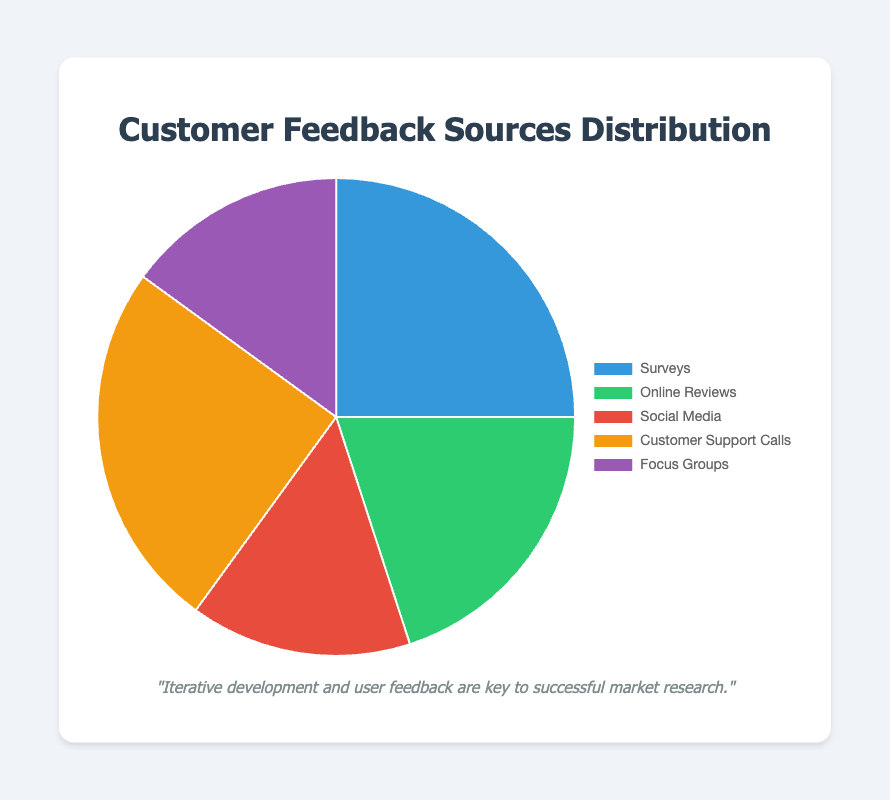What is the total percentage of feedback that comes from Surveys and Customer Support Calls? To find the total percentage of feedback that comes from Surveys and Customer Support Calls, we sum their percentages: 25% (Surveys) + 25% (Customer Support Calls) = 50%.
Answer: 50% Which feedback source contributes the least to the overall distribution? By comparing the given percentages, Social Media and Focus Groups both have the lowest contributions at 15% each.
Answer: Social Media and Focus Groups How much more feedback do Surveys generate compared to Social Media? Surveys generate 25% and Social Media generate 15%. The difference is 25% - 15% = 10%.
Answer: 10% What percentage of feedback comes from sources other than Online Reviews? To find the percentage of feedback from sources other than Online Reviews, we subtract the percentage of Online Reviews from 100%: 100% - 20% = 80%.
Answer: 80% Is the feedback from Customer Support Calls equal to that from Surveys? Yes, both Customer Support Calls and Surveys contribute 25% each to the overall distribution.
Answer: Yes Which sector provides more feedback: Focus Groups or Online Reviews? Online Reviews provide 20% of feedback while Focus Groups provide 15%. Thus, Online Reviews contribute more.
Answer: Online Reviews What is the average percentage of feedback for all sources? To find the average, sum up all the percentages and divide by the number of sources: (25% + 20% + 15% + 25% + 15%) / 5 = 20%.
Answer: 20% What feedback source is associated with the green color in the pie chart? By matching the color visually, Online Reviews are associated with the green segment in the pie chart.
Answer: Online Reviews How many sources provide less than 20% of the feedback? By examining the data, Social Media (15%) and Focus Groups (15%) provide less than 20%. So there are 2 sources.
Answer: 2 Is the feedback from Social Media and Focus Groups combined more than Customer Support Calls? Social Media and Focus Groups combined give 15% + 15% = 30%, which is more than Customer Support Calls at 25%.
Answer: Yes 